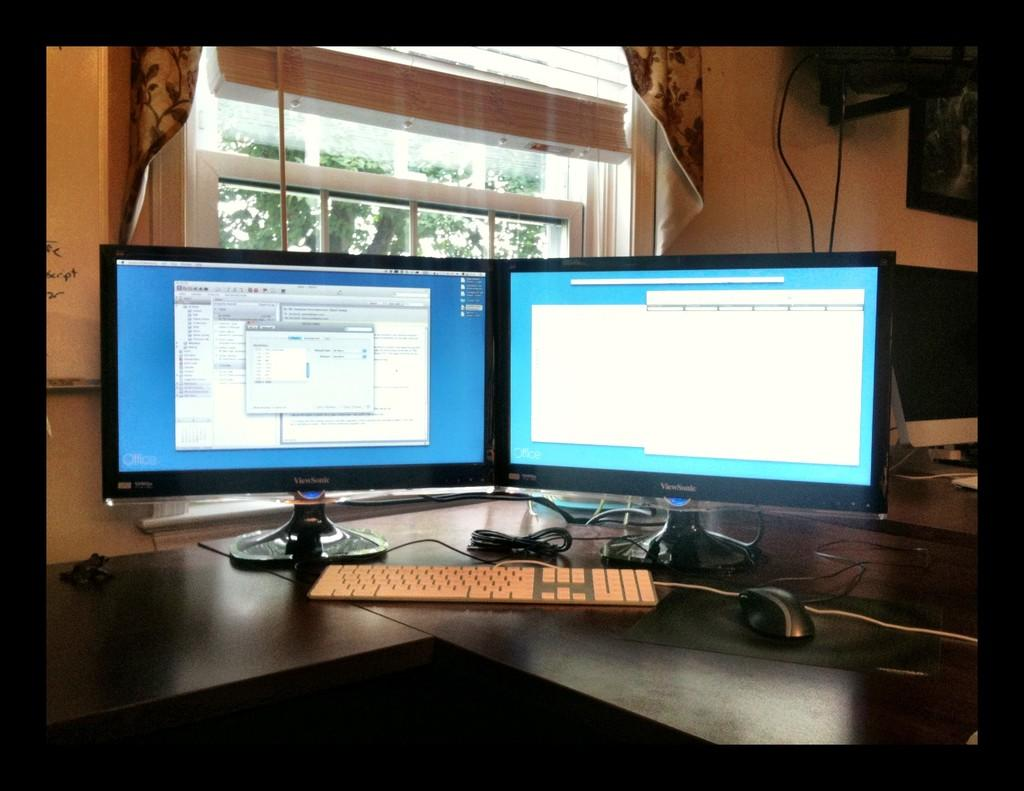<image>
Write a terse but informative summary of the picture. Two Viewsonic computer monitors stand by side with various open programs on them. 